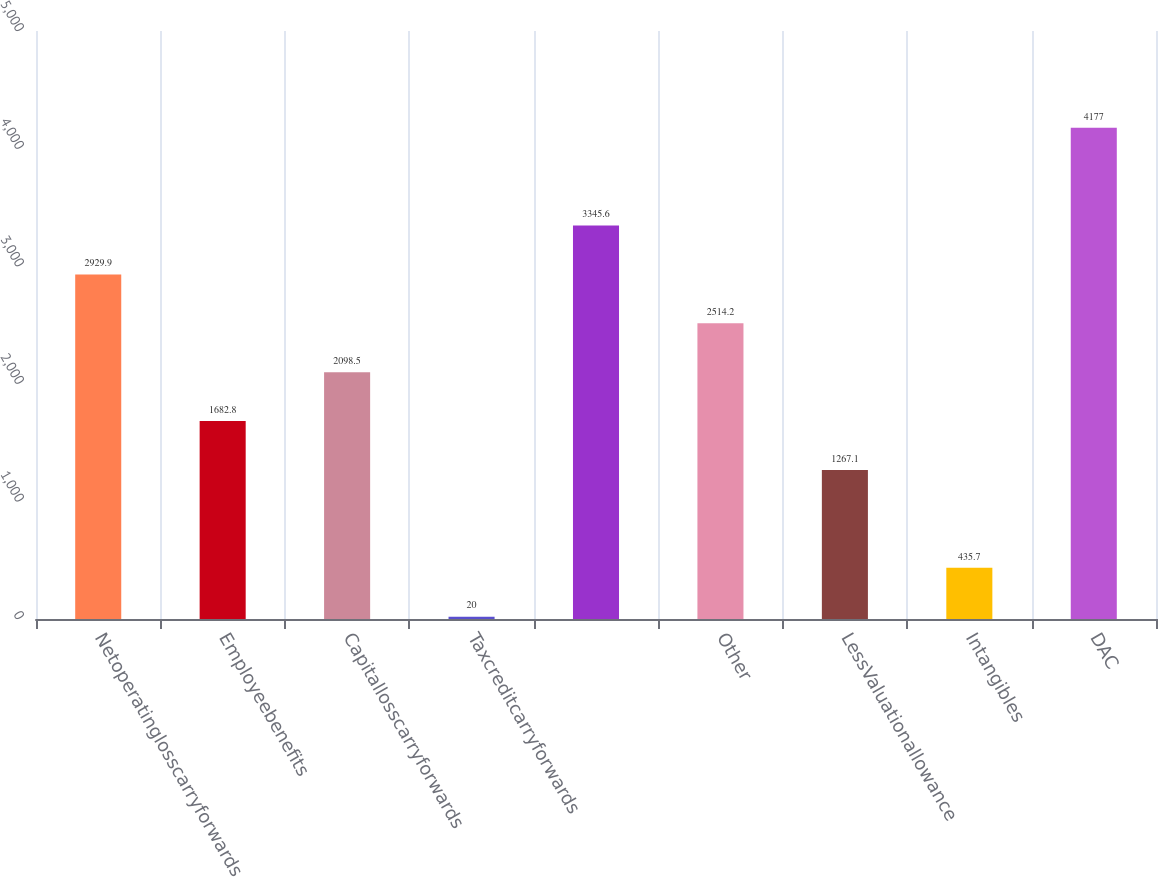Convert chart. <chart><loc_0><loc_0><loc_500><loc_500><bar_chart><fcel>Netoperatinglosscarryforwards<fcel>Employeebenefits<fcel>Capitallosscarryforwards<fcel>Taxcreditcarryforwards<fcel>Unnamed: 4<fcel>Other<fcel>LessValuationallowance<fcel>Intangibles<fcel>DAC<nl><fcel>2929.9<fcel>1682.8<fcel>2098.5<fcel>20<fcel>3345.6<fcel>2514.2<fcel>1267.1<fcel>435.7<fcel>4177<nl></chart> 